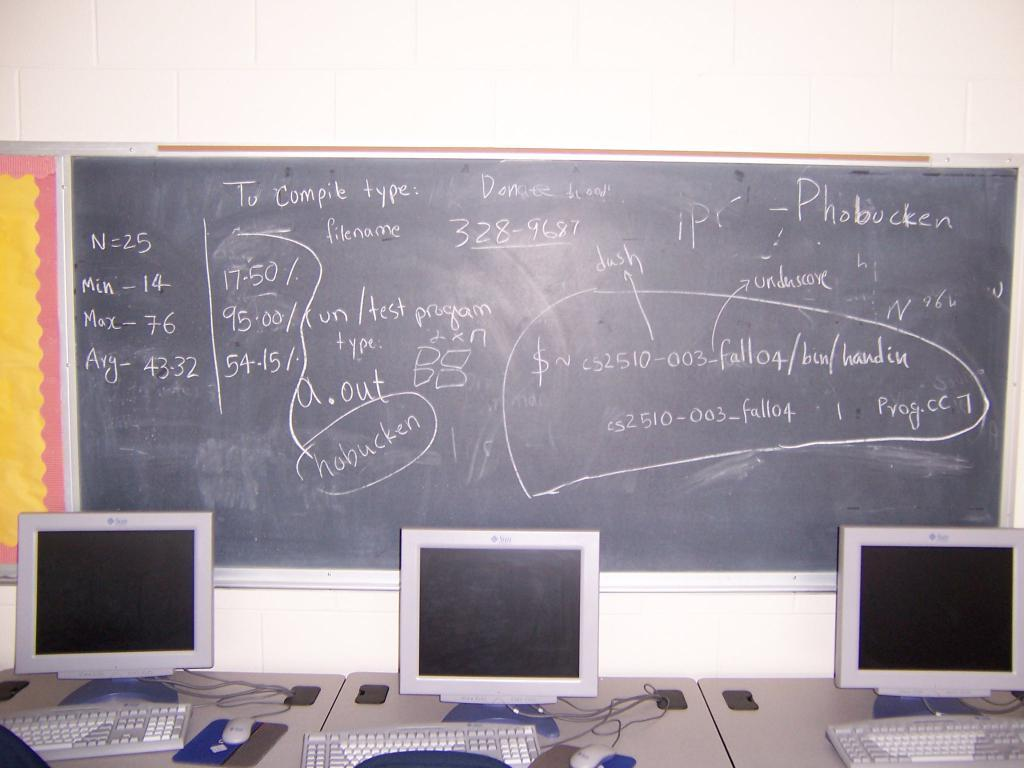What type of flooring is visible in the image? There are white color tiles in the image. What object can be seen in the image besides the flooring? There is a board in the image. What furniture is present in the image? There are tables in the image. What electronic devices are on the tables? Keyboards, mouses, and screens are present on the tables. What type of meat is being served on the board in the image? There is no meat present in the image; the board is not serving any food. Can you see any blood on the white tiles in the image? There is no blood visible on the white tiles in the image. 